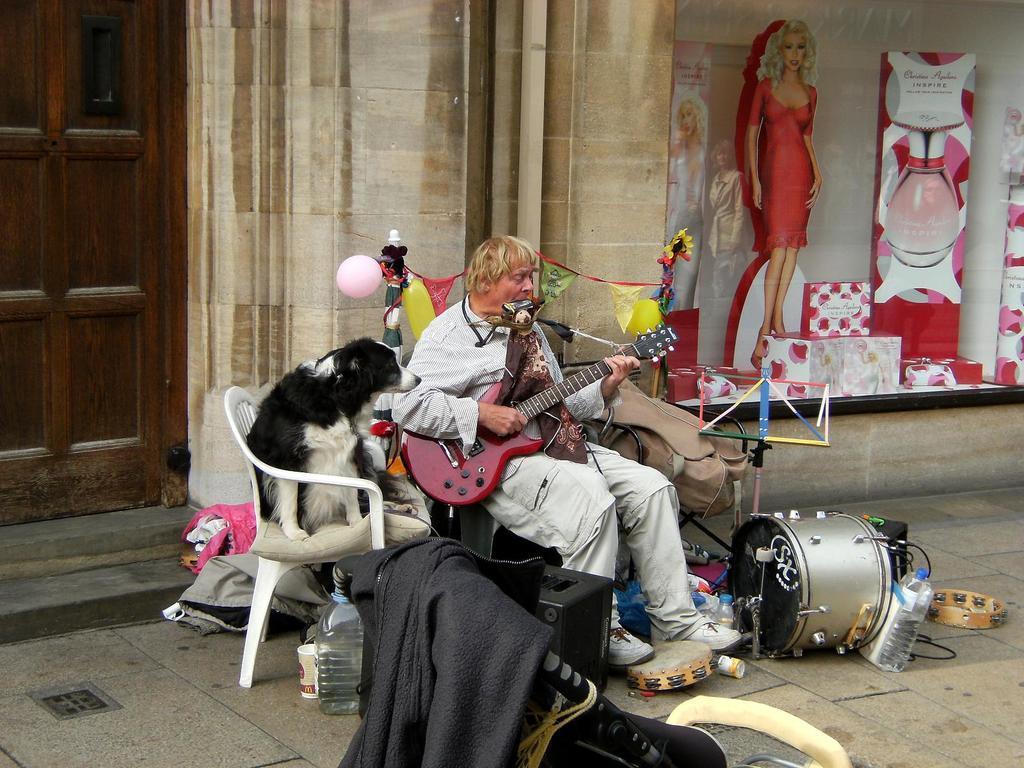Could you give a brief overview of what you see in this image? In this image there is a person sitting on a chair and playing guitar and there is a dog sitting on the chair beside this person. At the back there is a building, at the left there is a door, at the right there is a picture of a women, at the bottom there is a drum, bottle, wire and some clothes. 